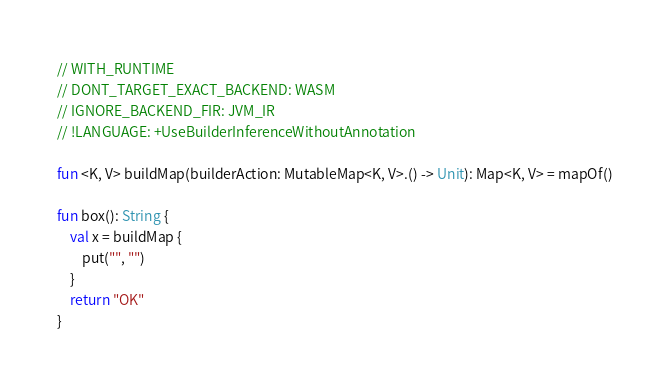Convert code to text. <code><loc_0><loc_0><loc_500><loc_500><_Kotlin_>// WITH_RUNTIME
// DONT_TARGET_EXACT_BACKEND: WASM
// IGNORE_BACKEND_FIR: JVM_IR
// !LANGUAGE: +UseBuilderInferenceWithoutAnnotation

fun <K, V> buildMap(builderAction: MutableMap<K, V>.() -> Unit): Map<K, V> = mapOf()

fun box(): String {
    val x = buildMap {
        put("", "")
    }
    return "OK"
}</code> 